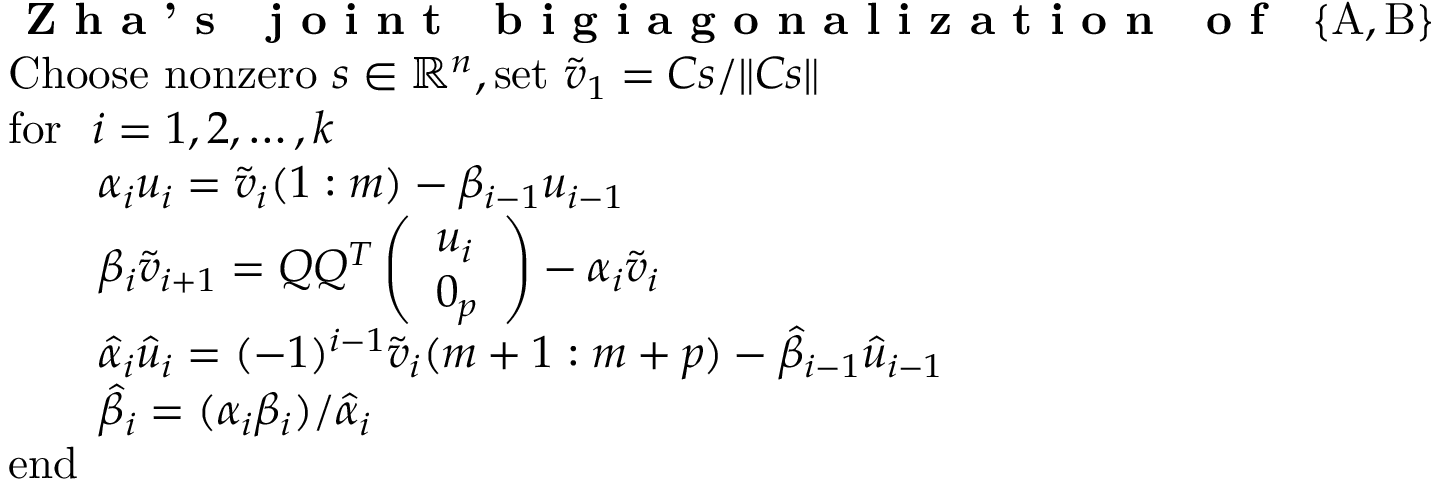Convert formula to latex. <formula><loc_0><loc_0><loc_500><loc_500>\begin{array} { r l } & { Z h a ^ { \prime } s j o i n t b i g i a g o n a l i z a t i o n o f \ \{ A , B \} } \\ & { C h o o s e n o n z e r o \ s \in \mathbb { R } ^ { n } , s e t \ \tilde { v } _ { 1 } = C s / \| C s \| } \\ & { f o r \ \ i = 1 , 2 , \dots , k } \\ & { \quad a l p h a _ { i } u _ { i } = \tilde { v } _ { i } ( 1 \colon m ) - \beta _ { i - 1 } u _ { i - 1 } } \\ & { \quad b e t a _ { i } \tilde { v } _ { i + 1 } = Q Q ^ { T } \left ( \begin{array} { l } { u _ { i } } \\ { 0 _ { p } } \end{array} \right ) - \alpha _ { i } \tilde { v } _ { i } } \\ & { \quad h a t { \alpha } _ { i } \hat { u } _ { i } = ( - 1 ) ^ { i - 1 } \tilde { v } _ { i } ( m + 1 \colon m + p ) - \hat { \beta } _ { i - 1 } \hat { u } _ { i - 1 } } \\ & { \quad h a t { \beta } _ { i } = ( \alpha _ { i } \beta _ { i } ) / \hat { \alpha } _ { i } } \\ & { e n d } \end{array}</formula> 